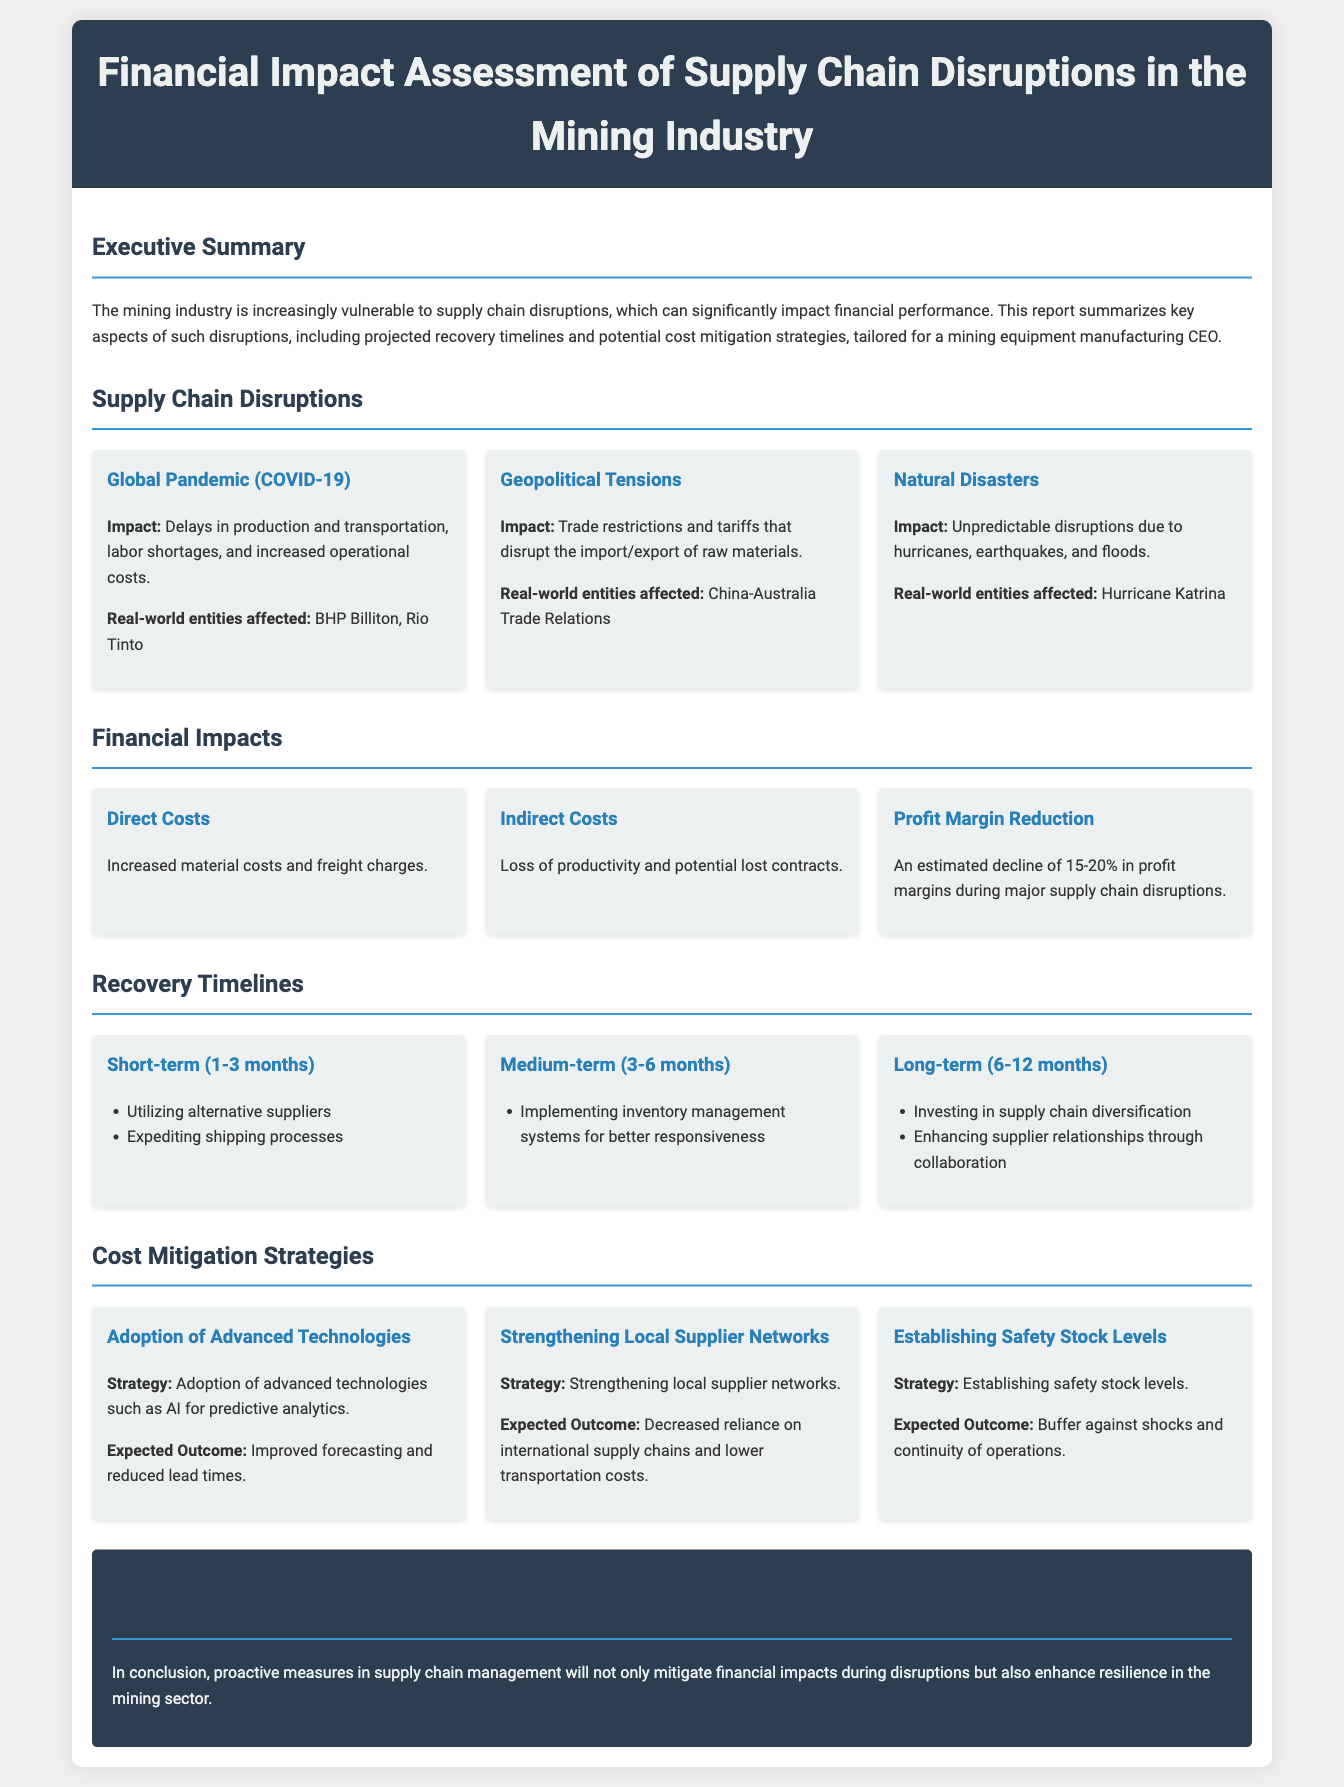What are the real-world entities affected by COVID-19 disruptions? The document lists specific entities impacted by supply chain disruptions, such as BHP Billiton and Rio Tinto under the COVID-19 section.
Answer: BHP Billiton, Rio Tinto What is the estimated decline in profit margins during major disruptions? The document states an estimated decline of 15-20% in profit margins during major supply chain disruptions.
Answer: 15-20% What is a short-term recovery strategy listed in the report? The report highlights utilizing alternative suppliers and expediting shipping processes as short-term recovery strategies.
Answer: Utilizing alternative suppliers What technology is suggested for predictive analytics? The report discusses the adoption of advanced technologies, specifically mentioning AI for predictive analytics.
Answer: AI What is one medium-term strategy listed in the recovery timelines? According to the document, implementing inventory management systems for better responsiveness is a medium-term strategy.
Answer: Implementing inventory management systems Which natural disaster was referenced in the report? The document mentions Hurricane Katrina as an example of a disruptive natural disaster in the mining industry.
Answer: Hurricane Katrina What is the expected outcome of strengthening local supplier networks? The document states that the expected outcome of strengthening local supplier networks is decreased reliance on international supply chains and lower transportation costs.
Answer: Decreased reliance on international supply chains What is a long-term strategy for recovery mentioned in the document? The report mentions investing in supply chain diversification as a long-term recovery strategy.
Answer: Investing in supply chain diversification 